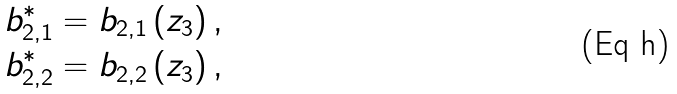Convert formula to latex. <formula><loc_0><loc_0><loc_500><loc_500>b _ { 2 , 1 } ^ { \ast } & = b _ { 2 , 1 } \left ( z _ { 3 } \right ) , \\ b _ { 2 , 2 } ^ { \ast } & = b _ { 2 , 2 } \left ( z _ { 3 } \right ) ,</formula> 